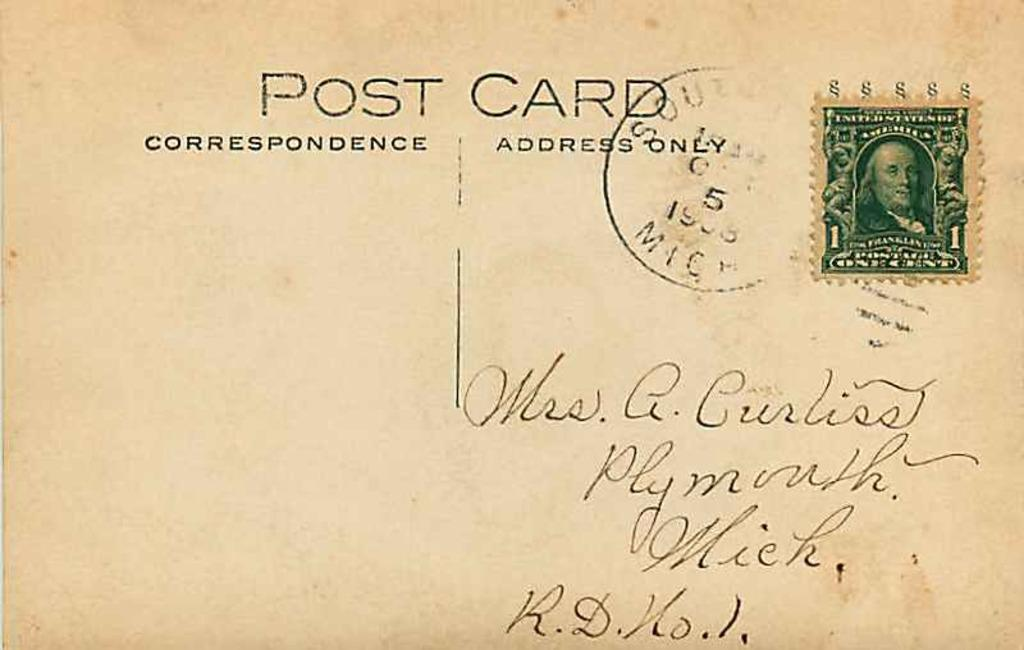<image>
Relay a brief, clear account of the picture shown. A postcard correspondence addressed to an individual in handwriting. 